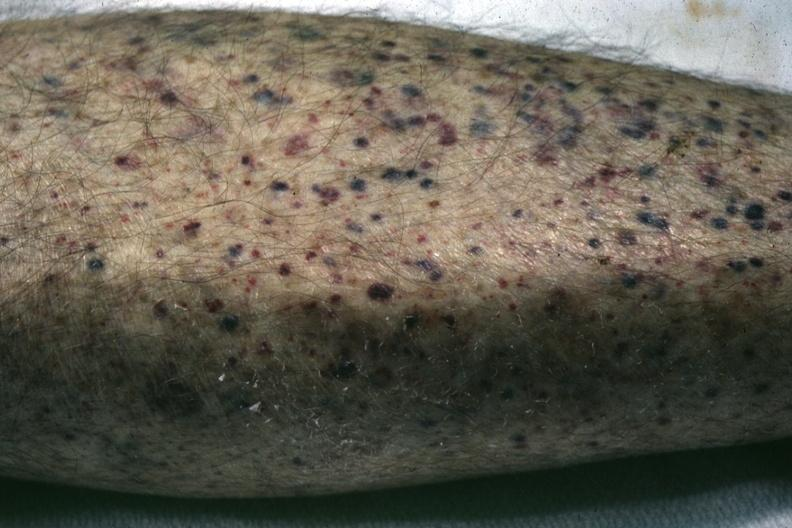s petechial and purpuric hemorrhages present?
Answer the question using a single word or phrase. Yes 